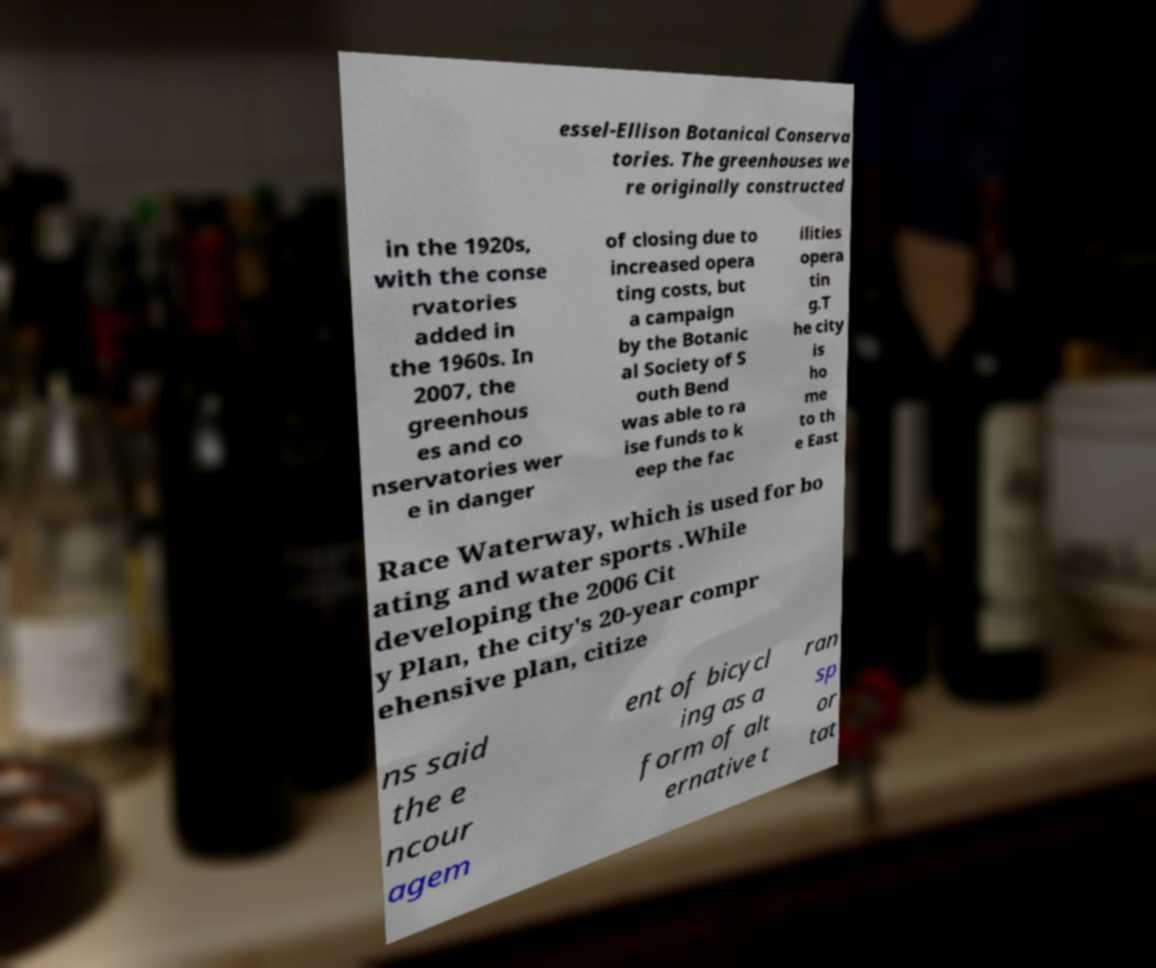Please identify and transcribe the text found in this image. essel-Ellison Botanical Conserva tories. The greenhouses we re originally constructed in the 1920s, with the conse rvatories added in the 1960s. In 2007, the greenhous es and co nservatories wer e in danger of closing due to increased opera ting costs, but a campaign by the Botanic al Society of S outh Bend was able to ra ise funds to k eep the fac ilities opera tin g.T he city is ho me to th e East Race Waterway, which is used for bo ating and water sports .While developing the 2006 Cit y Plan, the city's 20-year compr ehensive plan, citize ns said the e ncour agem ent of bicycl ing as a form of alt ernative t ran sp or tat 